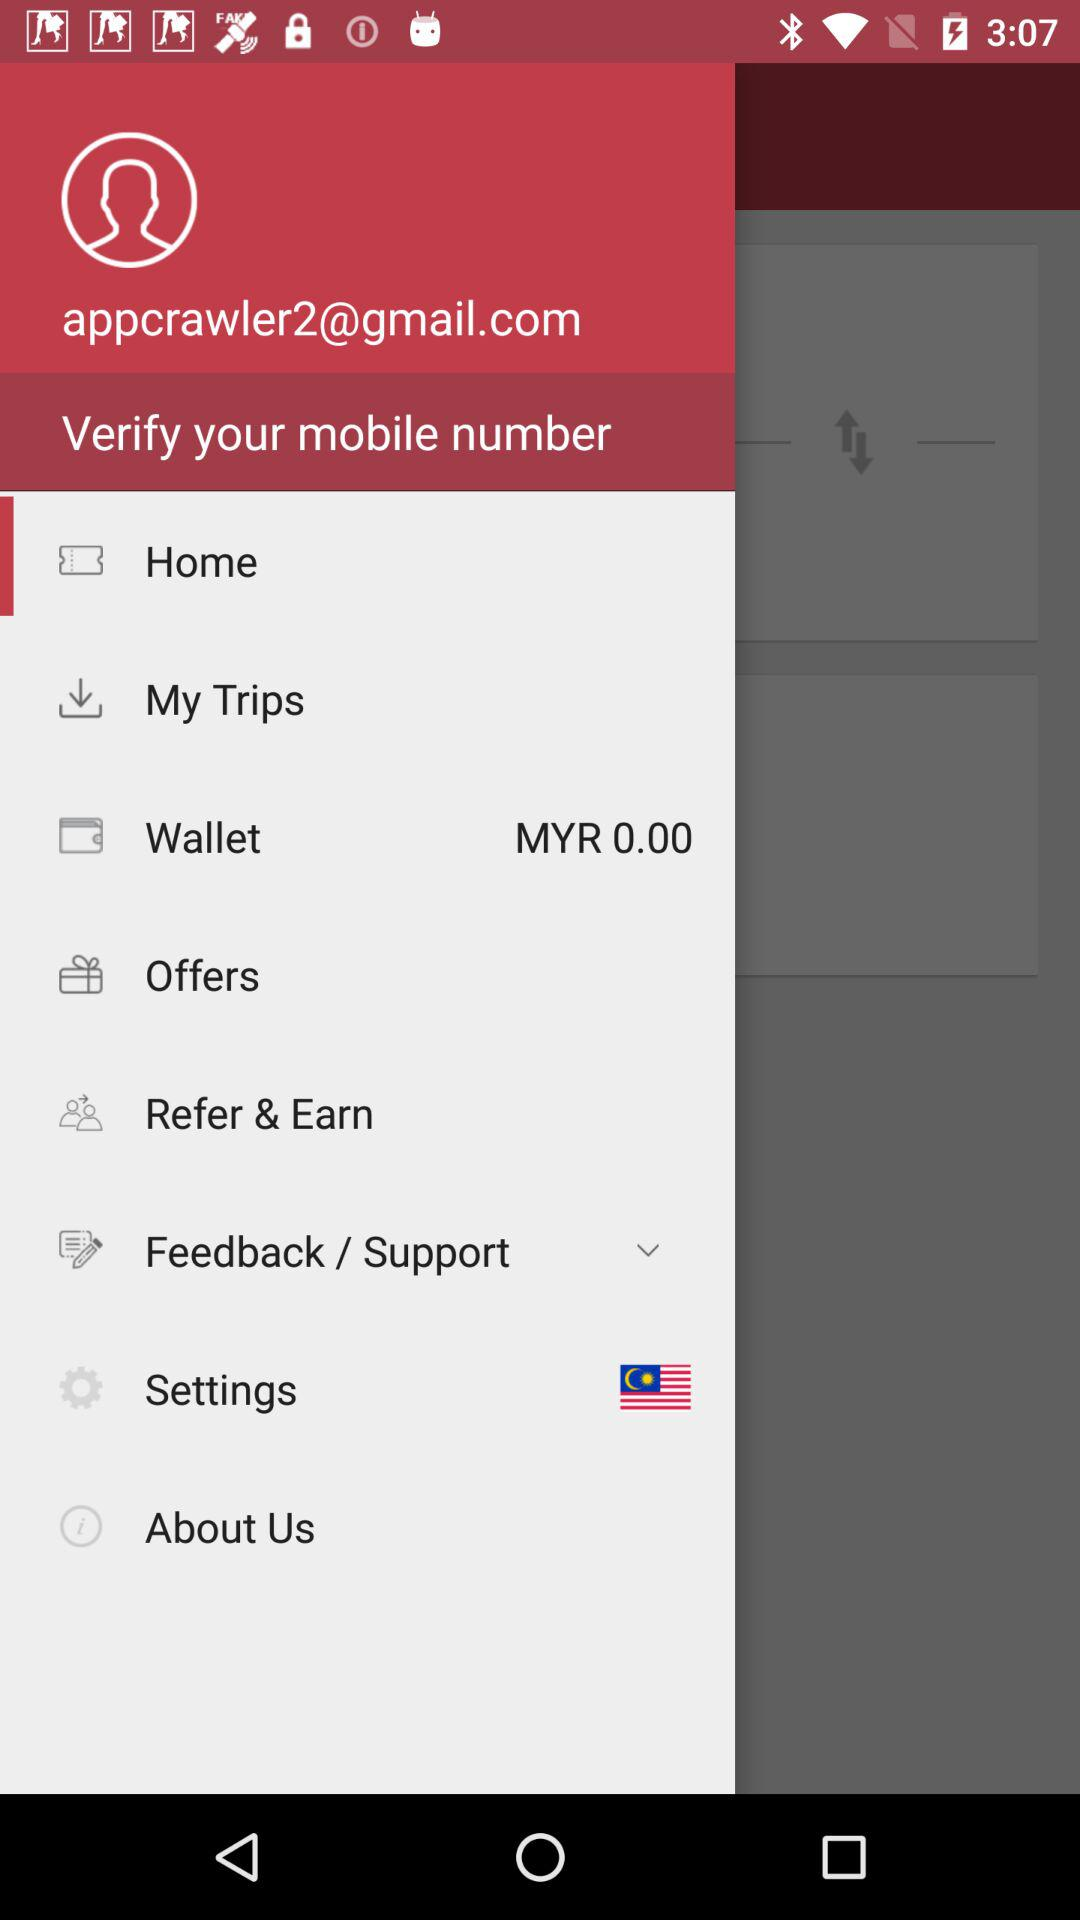How many items have a dollar amount of 0.00?
Answer the question using a single word or phrase. 1 